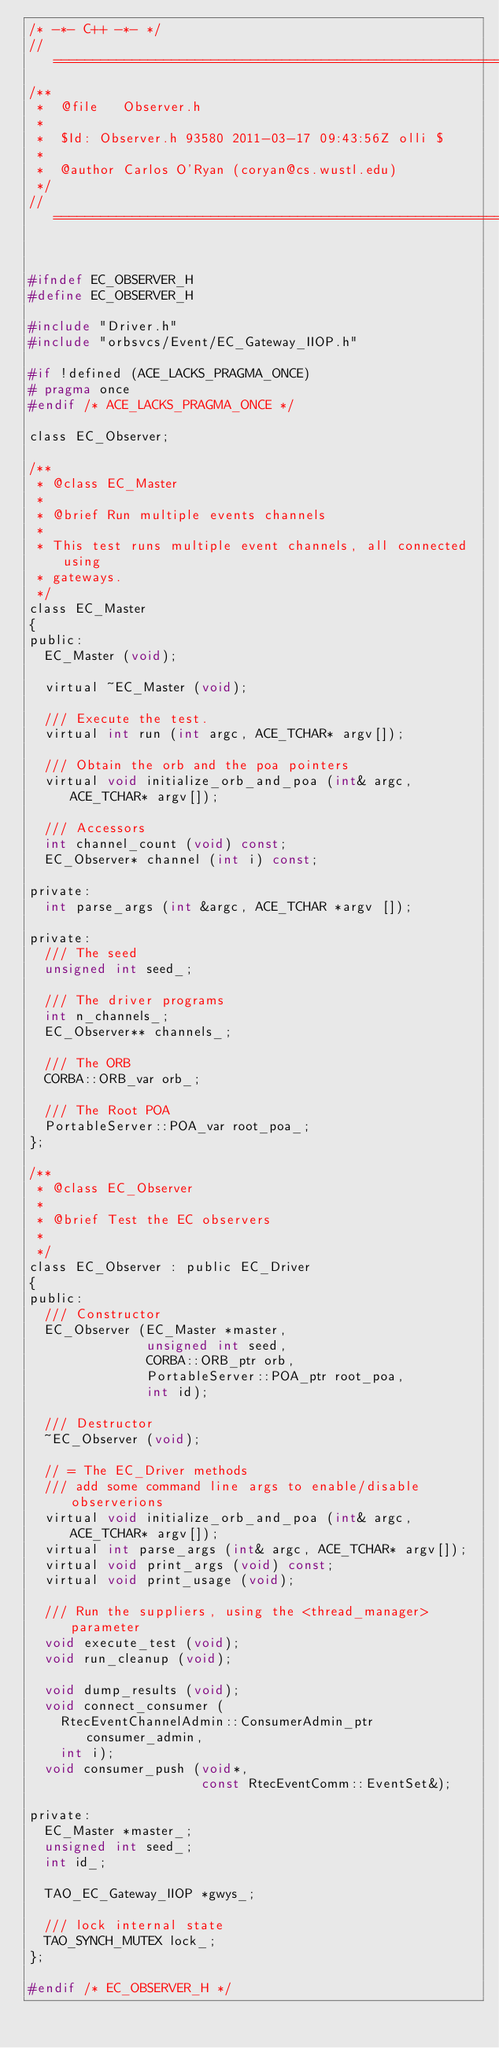Convert code to text. <code><loc_0><loc_0><loc_500><loc_500><_C_>/* -*- C++ -*- */
//=============================================================================
/**
 *  @file   Observer.h
 *
 *  $Id: Observer.h 93580 2011-03-17 09:43:56Z olli $
 *
 *  @author Carlos O'Ryan (coryan@cs.wustl.edu)
 */
//=============================================================================


#ifndef EC_OBSERVER_H
#define EC_OBSERVER_H

#include "Driver.h"
#include "orbsvcs/Event/EC_Gateway_IIOP.h"

#if !defined (ACE_LACKS_PRAGMA_ONCE)
# pragma once
#endif /* ACE_LACKS_PRAGMA_ONCE */

class EC_Observer;

/**
 * @class EC_Master
 *
 * @brief Run multiple events channels
 *
 * This test runs multiple event channels, all connected using
 * gateways.
 */
class EC_Master
{
public:
  EC_Master (void);

  virtual ~EC_Master (void);

  /// Execute the test.
  virtual int run (int argc, ACE_TCHAR* argv[]);

  /// Obtain the orb and the poa pointers
  virtual void initialize_orb_and_poa (int& argc, ACE_TCHAR* argv[]);

  /// Accessors
  int channel_count (void) const;
  EC_Observer* channel (int i) const;

private:
  int parse_args (int &argc, ACE_TCHAR *argv []);

private:
  /// The seed
  unsigned int seed_;

  /// The driver programs
  int n_channels_;
  EC_Observer** channels_;

  /// The ORB
  CORBA::ORB_var orb_;

  /// The Root POA
  PortableServer::POA_var root_poa_;
};

/**
 * @class EC_Observer
 *
 * @brief Test the EC observers
 *
 */
class EC_Observer : public EC_Driver
{
public:
  /// Constructor
  EC_Observer (EC_Master *master,
               unsigned int seed,
               CORBA::ORB_ptr orb,
               PortableServer::POA_ptr root_poa,
               int id);

  /// Destructor
  ~EC_Observer (void);

  // = The EC_Driver methods
  /// add some command line args to enable/disable observerions
  virtual void initialize_orb_and_poa (int& argc, ACE_TCHAR* argv[]);
  virtual int parse_args (int& argc, ACE_TCHAR* argv[]);
  virtual void print_args (void) const;
  virtual void print_usage (void);

  /// Run the suppliers, using the <thread_manager> parameter
  void execute_test (void);
  void run_cleanup (void);

  void dump_results (void);
  void connect_consumer (
    RtecEventChannelAdmin::ConsumerAdmin_ptr consumer_admin,
    int i);
  void consumer_push (void*,
                      const RtecEventComm::EventSet&);

private:
  EC_Master *master_;
  unsigned int seed_;
  int id_;

  TAO_EC_Gateway_IIOP *gwys_;

  /// lock internal state
  TAO_SYNCH_MUTEX lock_;
};

#endif /* EC_OBSERVER_H */
</code> 